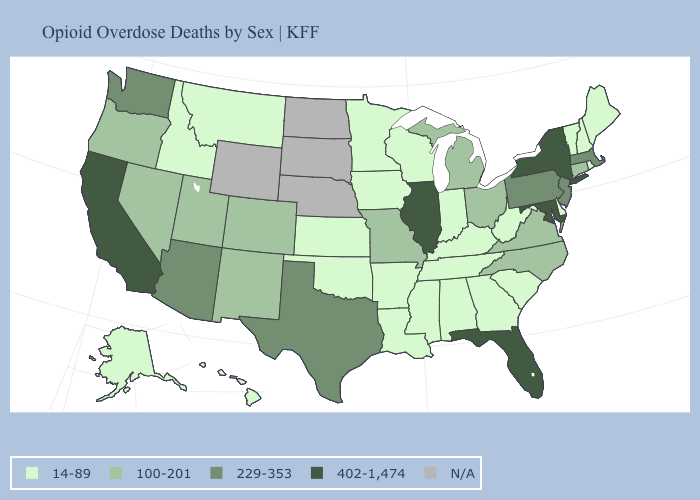What is the value of Hawaii?
Short answer required. 14-89. Is the legend a continuous bar?
Short answer required. No. Among the states that border Indiana , does Kentucky have the lowest value?
Keep it brief. Yes. Is the legend a continuous bar?
Keep it brief. No. Does Pennsylvania have the lowest value in the Northeast?
Be succinct. No. Name the states that have a value in the range N/A?
Short answer required. Nebraska, North Dakota, South Dakota, Wyoming. Which states have the highest value in the USA?
Short answer required. California, Florida, Illinois, Maryland, New York. Does the first symbol in the legend represent the smallest category?
Keep it brief. Yes. What is the value of Maryland?
Answer briefly. 402-1,474. Does the map have missing data?
Keep it brief. Yes. What is the value of Texas?
Keep it brief. 229-353. Name the states that have a value in the range 14-89?
Keep it brief. Alabama, Alaska, Arkansas, Delaware, Georgia, Hawaii, Idaho, Indiana, Iowa, Kansas, Kentucky, Louisiana, Maine, Minnesota, Mississippi, Montana, New Hampshire, Oklahoma, Rhode Island, South Carolina, Tennessee, Vermont, West Virginia, Wisconsin. What is the value of South Carolina?
Quick response, please. 14-89. Which states have the lowest value in the USA?
Keep it brief. Alabama, Alaska, Arkansas, Delaware, Georgia, Hawaii, Idaho, Indiana, Iowa, Kansas, Kentucky, Louisiana, Maine, Minnesota, Mississippi, Montana, New Hampshire, Oklahoma, Rhode Island, South Carolina, Tennessee, Vermont, West Virginia, Wisconsin. 